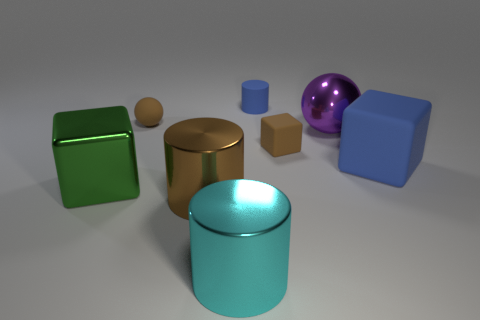Subtract all cyan metal cylinders. How many cylinders are left? 2 Add 1 metallic balls. How many objects exist? 9 Subtract all purple balls. How many balls are left? 1 Subtract 1 blocks. How many blocks are left? 2 Subtract all cubes. How many objects are left? 5 Subtract all purple cylinders. Subtract all red balls. How many cylinders are left? 3 Subtract all small brown blocks. Subtract all purple objects. How many objects are left? 6 Add 8 large blue rubber objects. How many large blue rubber objects are left? 9 Add 1 blue things. How many blue things exist? 3 Subtract 1 cyan cylinders. How many objects are left? 7 